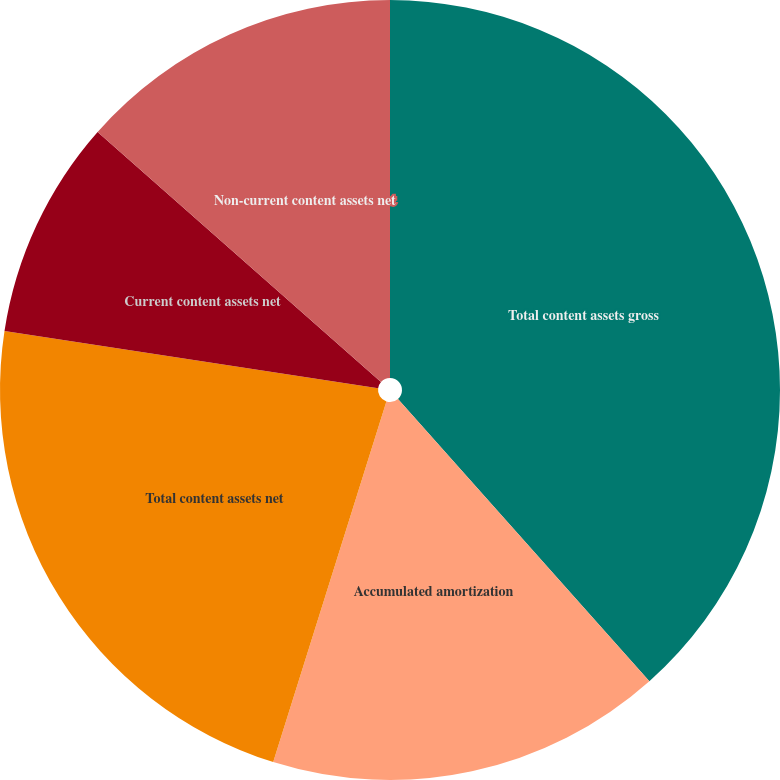Convert chart to OTSL. <chart><loc_0><loc_0><loc_500><loc_500><pie_chart><fcel>Total content assets gross<fcel>Accumulated amortization<fcel>Total content assets net<fcel>Current content assets net<fcel>Non-current content assets net<nl><fcel>38.42%<fcel>16.42%<fcel>22.58%<fcel>9.09%<fcel>13.49%<nl></chart> 